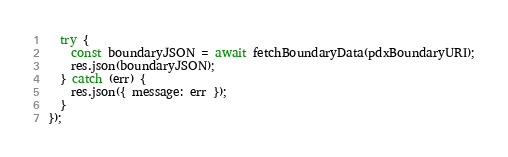<code> <loc_0><loc_0><loc_500><loc_500><_JavaScript_>  try {
    const boundaryJSON = await fetchBoundaryData(pdxBoundaryURI);
    res.json(boundaryJSON);
  } catch (err) {
    res.json({ message: err });
  }
});
</code> 